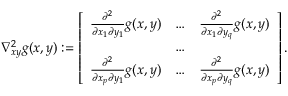Convert formula to latex. <formula><loc_0><loc_0><loc_500><loc_500>\nabla _ { x y } ^ { 2 } g ( x , y ) \colon = \left [ \begin{array} { l l l } { \frac { \partial ^ { 2 } } { \partial x _ { 1 } \partial y _ { 1 } } g ( x , y ) } & { \dots } & { \frac { \partial ^ { 2 } } { \partial x _ { 1 } \partial y _ { q } } g ( x , y ) } \\ & { \dots } & \\ { \frac { \partial ^ { 2 } } { \partial x _ { p } \partial y _ { 1 } } g ( x , y ) } & { \dots } & { \frac { \partial ^ { 2 } } { \partial x _ { p } \partial y _ { q } } g ( x , y ) } \end{array} \right ] .</formula> 